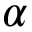Convert formula to latex. <formula><loc_0><loc_0><loc_500><loc_500>\alpha</formula> 